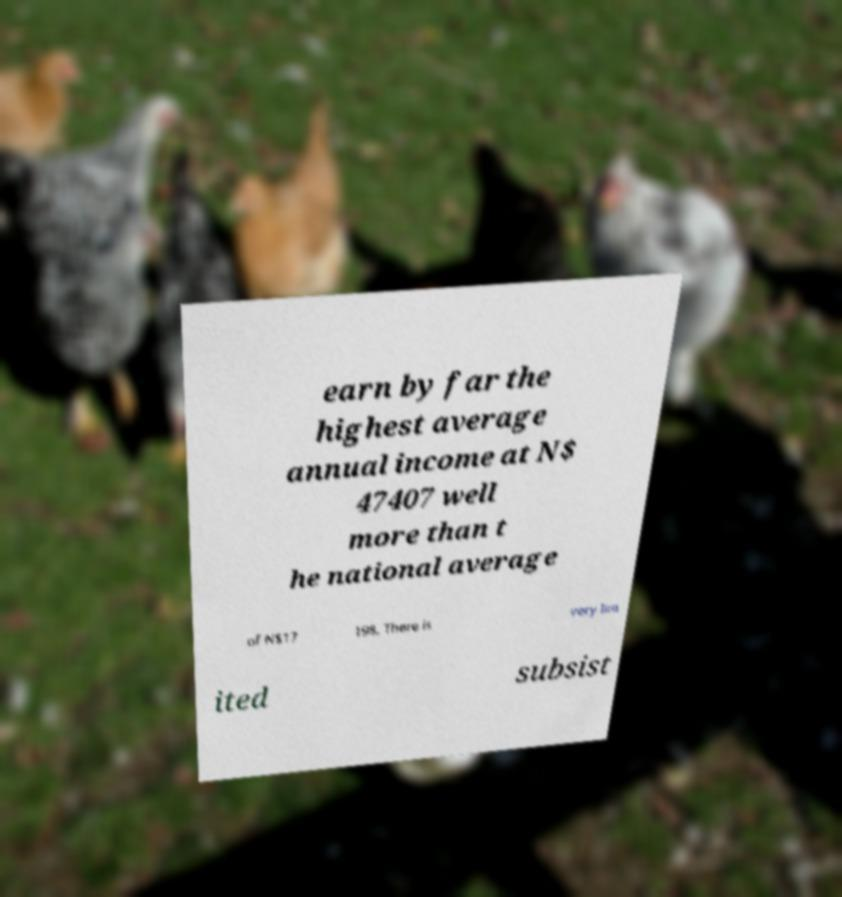Please identify and transcribe the text found in this image. earn by far the highest average annual income at N$ 47407 well more than t he national average of N$17 198. There is very lim ited subsist 